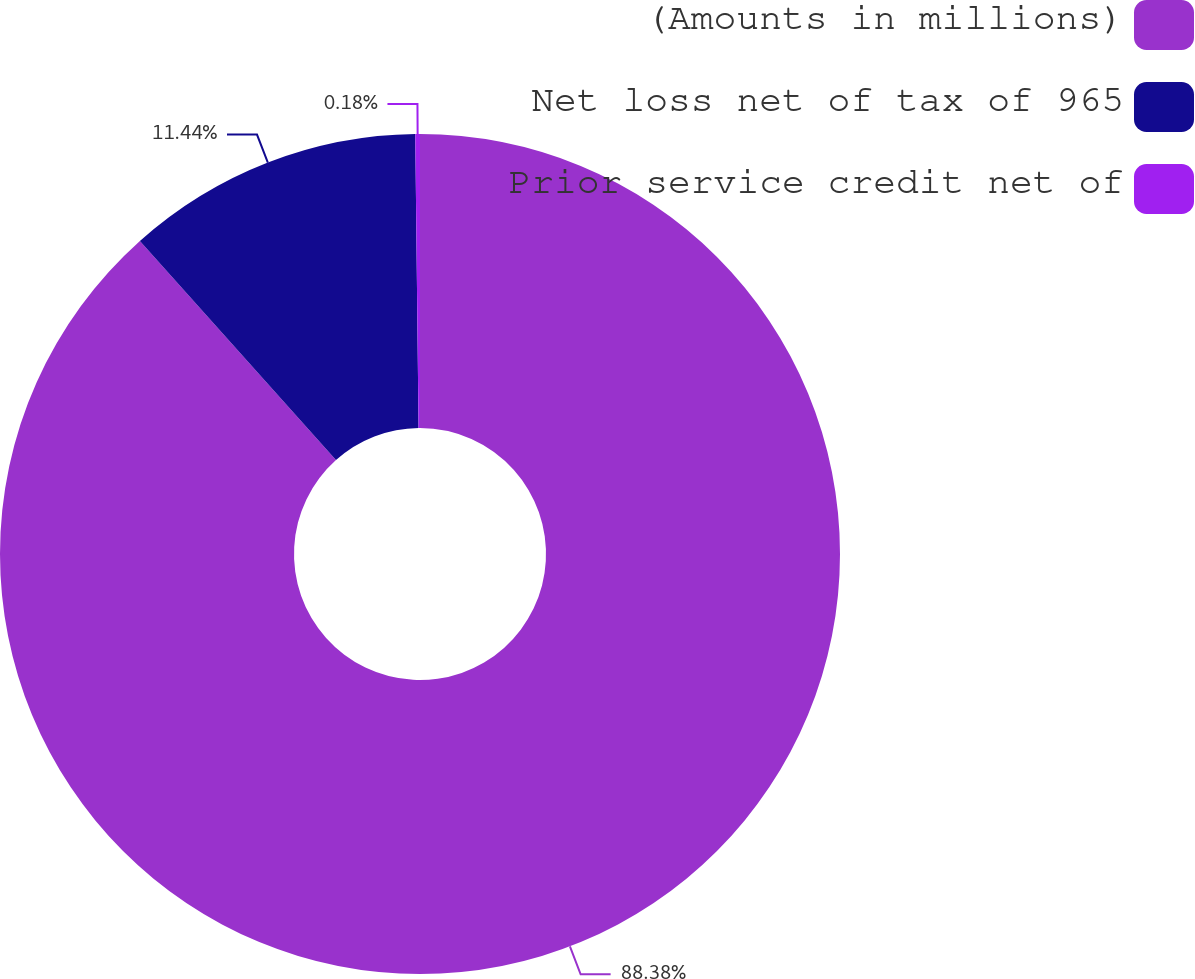Convert chart. <chart><loc_0><loc_0><loc_500><loc_500><pie_chart><fcel>(Amounts in millions)<fcel>Net loss net of tax of 965<fcel>Prior service credit net of<nl><fcel>88.39%<fcel>11.44%<fcel>0.18%<nl></chart> 